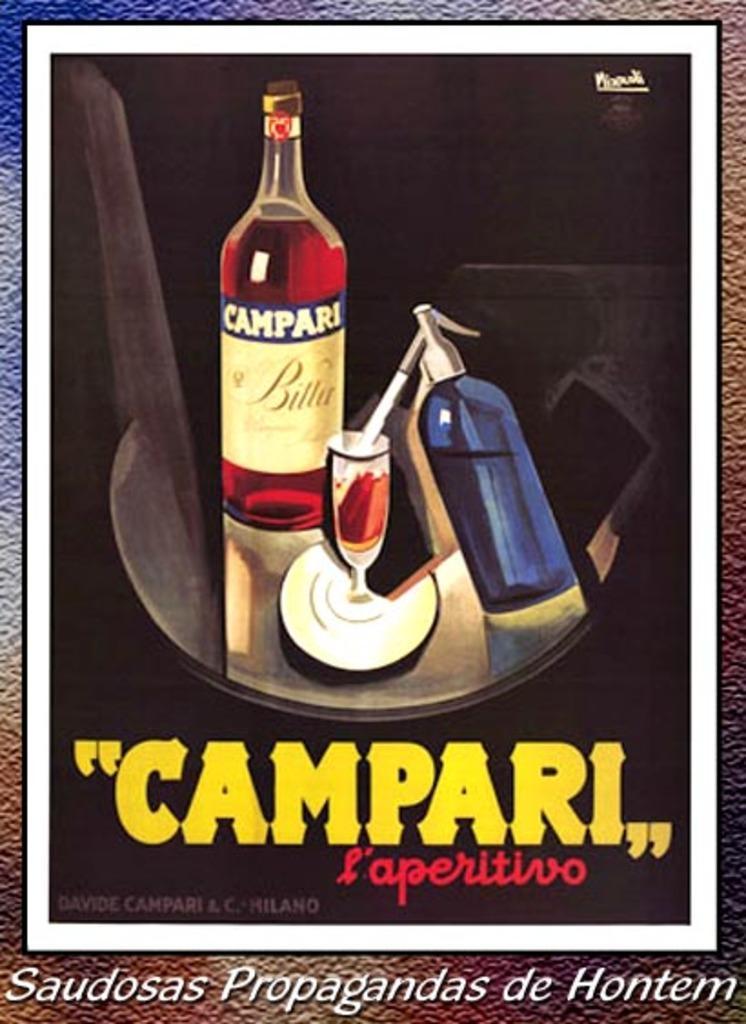Please provide a concise description of this image. This is the picture of a poster in which there are two bottles, glass and something written on it. 